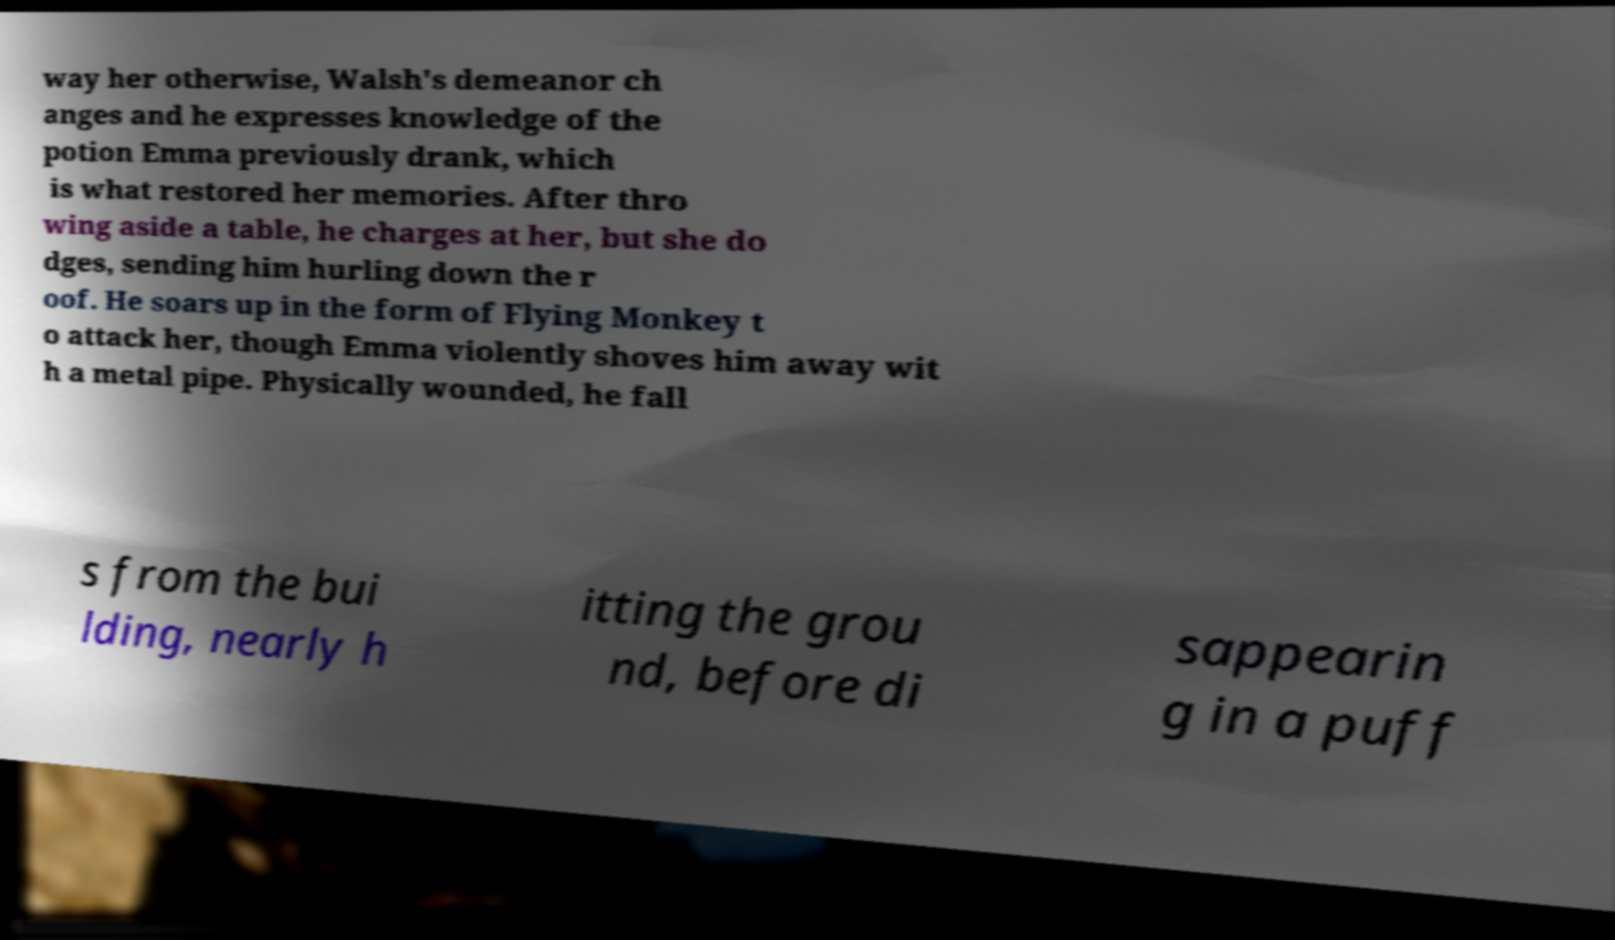For documentation purposes, I need the text within this image transcribed. Could you provide that? way her otherwise, Walsh's demeanor ch anges and he expresses knowledge of the potion Emma previously drank, which is what restored her memories. After thro wing aside a table, he charges at her, but she do dges, sending him hurling down the r oof. He soars up in the form of Flying Monkey t o attack her, though Emma violently shoves him away wit h a metal pipe. Physically wounded, he fall s from the bui lding, nearly h itting the grou nd, before di sappearin g in a puff 